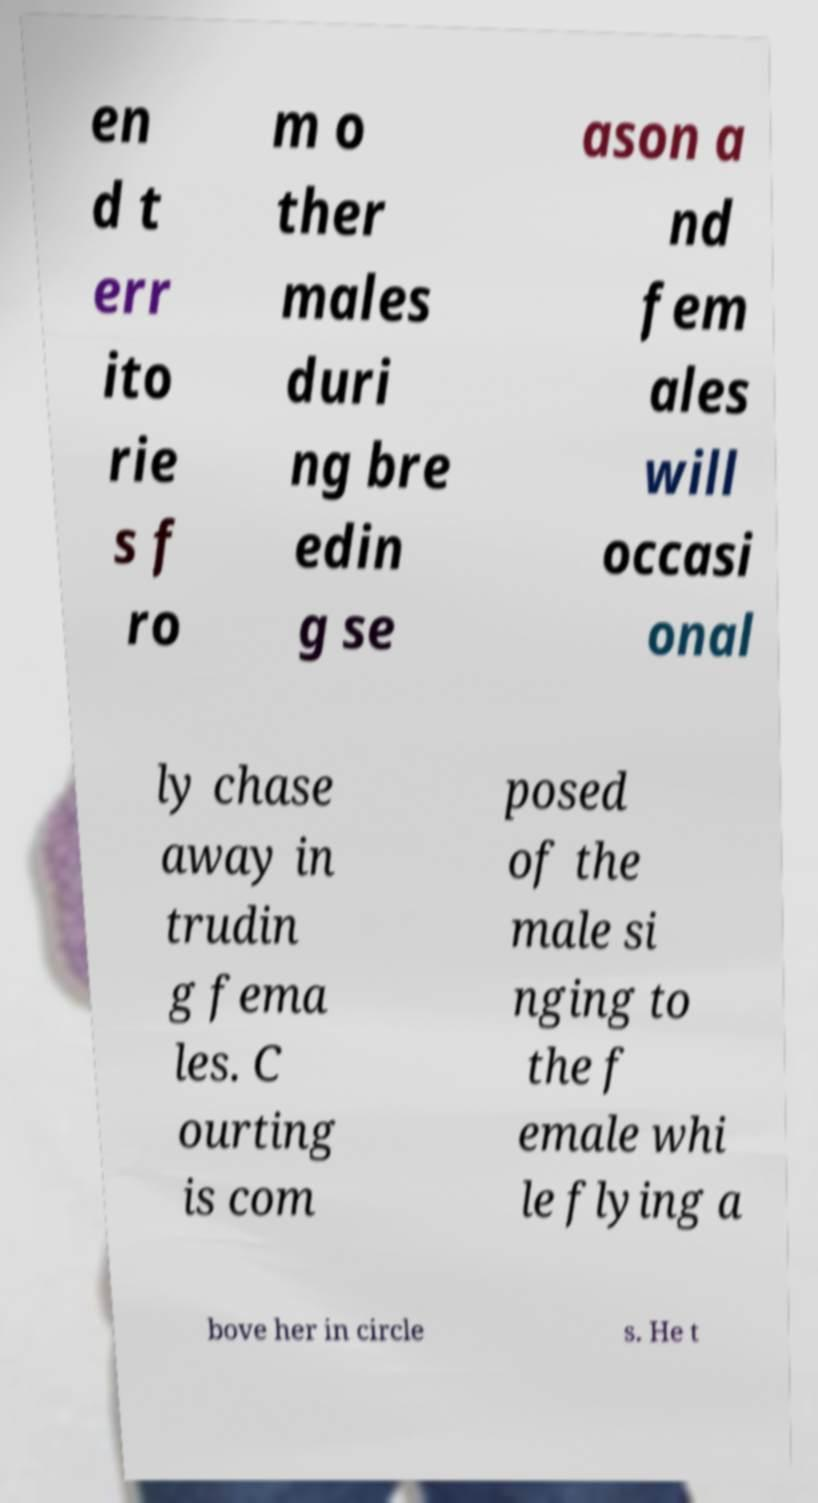Please read and relay the text visible in this image. What does it say? en d t err ito rie s f ro m o ther males duri ng bre edin g se ason a nd fem ales will occasi onal ly chase away in trudin g fema les. C ourting is com posed of the male si nging to the f emale whi le flying a bove her in circle s. He t 